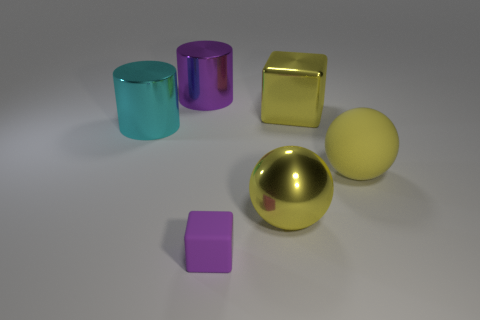Is the number of purple cylinders that are in front of the yellow cube greater than the number of small cyan matte blocks?
Provide a succinct answer. No. What number of yellow cubes have the same size as the purple shiny cylinder?
Provide a short and direct response. 1. There is a metal ball that is the same color as the rubber sphere; what is its size?
Ensure brevity in your answer.  Large. How many big objects are either purple metallic blocks or cyan objects?
Offer a terse response. 1. How many yellow metallic objects are there?
Provide a short and direct response. 2. Are there the same number of big spheres that are on the left side of the big rubber sphere and purple cubes that are on the left side of the big purple shiny thing?
Provide a short and direct response. No. There is a large cyan shiny object; are there any tiny purple cubes behind it?
Provide a short and direct response. No. The large metallic cylinder in front of the purple cylinder is what color?
Ensure brevity in your answer.  Cyan. What material is the sphere on the right side of the metal block that is on the right side of the large purple metal cylinder made of?
Ensure brevity in your answer.  Rubber. Are there fewer large yellow balls behind the big yellow matte sphere than yellow things to the left of the big yellow metallic ball?
Offer a very short reply. No. 